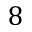<formula> <loc_0><loc_0><loc_500><loc_500>8</formula> 